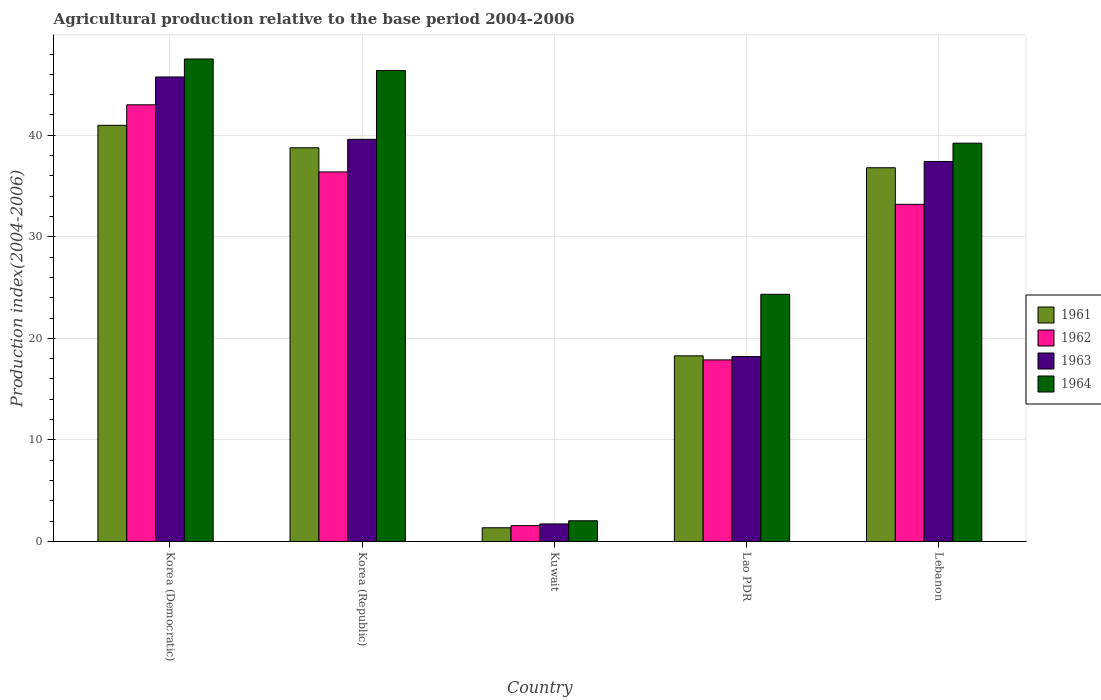How many different coloured bars are there?
Make the answer very short. 4. How many bars are there on the 5th tick from the left?
Provide a short and direct response. 4. How many bars are there on the 2nd tick from the right?
Your answer should be compact. 4. What is the label of the 5th group of bars from the left?
Provide a short and direct response. Lebanon. In how many cases, is the number of bars for a given country not equal to the number of legend labels?
Ensure brevity in your answer.  0. What is the agricultural production index in 1962 in Korea (Democratic)?
Offer a terse response. 43. Across all countries, what is the maximum agricultural production index in 1963?
Your response must be concise. 45.74. Across all countries, what is the minimum agricultural production index in 1962?
Offer a very short reply. 1.56. In which country was the agricultural production index in 1963 maximum?
Your answer should be very brief. Korea (Democratic). In which country was the agricultural production index in 1962 minimum?
Offer a very short reply. Kuwait. What is the total agricultural production index in 1963 in the graph?
Provide a succinct answer. 142.7. What is the difference between the agricultural production index in 1963 in Korea (Democratic) and that in Kuwait?
Offer a terse response. 44.01. What is the difference between the agricultural production index in 1962 in Lebanon and the agricultural production index in 1963 in Kuwait?
Your response must be concise. 31.47. What is the average agricultural production index in 1964 per country?
Ensure brevity in your answer.  31.9. What is the difference between the agricultural production index of/in 1962 and agricultural production index of/in 1963 in Kuwait?
Your answer should be very brief. -0.17. What is the ratio of the agricultural production index in 1962 in Korea (Republic) to that in Lao PDR?
Make the answer very short. 2.04. What is the difference between the highest and the second highest agricultural production index in 1961?
Make the answer very short. 4.18. What is the difference between the highest and the lowest agricultural production index in 1964?
Provide a short and direct response. 45.47. Is the sum of the agricultural production index in 1962 in Kuwait and Lebanon greater than the maximum agricultural production index in 1963 across all countries?
Your answer should be compact. No. Is it the case that in every country, the sum of the agricultural production index in 1962 and agricultural production index in 1961 is greater than the sum of agricultural production index in 1963 and agricultural production index in 1964?
Your answer should be very brief. No. What does the 4th bar from the left in Lao PDR represents?
Offer a terse response. 1964. What does the 4th bar from the right in Lao PDR represents?
Provide a succinct answer. 1961. Are the values on the major ticks of Y-axis written in scientific E-notation?
Offer a very short reply. No. Does the graph contain any zero values?
Your response must be concise. No. Where does the legend appear in the graph?
Provide a short and direct response. Center right. How many legend labels are there?
Your answer should be very brief. 4. How are the legend labels stacked?
Provide a succinct answer. Vertical. What is the title of the graph?
Offer a terse response. Agricultural production relative to the base period 2004-2006. Does "1975" appear as one of the legend labels in the graph?
Your response must be concise. No. What is the label or title of the Y-axis?
Provide a short and direct response. Production index(2004-2006). What is the Production index(2004-2006) of 1961 in Korea (Democratic)?
Make the answer very short. 40.98. What is the Production index(2004-2006) of 1962 in Korea (Democratic)?
Provide a short and direct response. 43. What is the Production index(2004-2006) in 1963 in Korea (Democratic)?
Your answer should be compact. 45.74. What is the Production index(2004-2006) in 1964 in Korea (Democratic)?
Offer a terse response. 47.51. What is the Production index(2004-2006) of 1961 in Korea (Republic)?
Provide a succinct answer. 38.77. What is the Production index(2004-2006) of 1962 in Korea (Republic)?
Offer a terse response. 36.39. What is the Production index(2004-2006) in 1963 in Korea (Republic)?
Your answer should be compact. 39.6. What is the Production index(2004-2006) in 1964 in Korea (Republic)?
Your response must be concise. 46.37. What is the Production index(2004-2006) in 1961 in Kuwait?
Ensure brevity in your answer.  1.35. What is the Production index(2004-2006) in 1962 in Kuwait?
Your answer should be compact. 1.56. What is the Production index(2004-2006) in 1963 in Kuwait?
Offer a terse response. 1.73. What is the Production index(2004-2006) in 1964 in Kuwait?
Your response must be concise. 2.04. What is the Production index(2004-2006) in 1961 in Lao PDR?
Make the answer very short. 18.28. What is the Production index(2004-2006) in 1962 in Lao PDR?
Provide a short and direct response. 17.88. What is the Production index(2004-2006) of 1963 in Lao PDR?
Make the answer very short. 18.21. What is the Production index(2004-2006) of 1964 in Lao PDR?
Offer a terse response. 24.34. What is the Production index(2004-2006) of 1961 in Lebanon?
Your response must be concise. 36.8. What is the Production index(2004-2006) in 1962 in Lebanon?
Offer a very short reply. 33.2. What is the Production index(2004-2006) of 1963 in Lebanon?
Your answer should be very brief. 37.42. What is the Production index(2004-2006) in 1964 in Lebanon?
Keep it short and to the point. 39.22. Across all countries, what is the maximum Production index(2004-2006) in 1961?
Keep it short and to the point. 40.98. Across all countries, what is the maximum Production index(2004-2006) in 1962?
Offer a very short reply. 43. Across all countries, what is the maximum Production index(2004-2006) of 1963?
Provide a succinct answer. 45.74. Across all countries, what is the maximum Production index(2004-2006) in 1964?
Your answer should be compact. 47.51. Across all countries, what is the minimum Production index(2004-2006) of 1961?
Offer a terse response. 1.35. Across all countries, what is the minimum Production index(2004-2006) of 1962?
Provide a succinct answer. 1.56. Across all countries, what is the minimum Production index(2004-2006) of 1963?
Make the answer very short. 1.73. Across all countries, what is the minimum Production index(2004-2006) in 1964?
Your answer should be very brief. 2.04. What is the total Production index(2004-2006) in 1961 in the graph?
Make the answer very short. 136.18. What is the total Production index(2004-2006) in 1962 in the graph?
Your answer should be compact. 132.03. What is the total Production index(2004-2006) in 1963 in the graph?
Your answer should be very brief. 142.7. What is the total Production index(2004-2006) in 1964 in the graph?
Give a very brief answer. 159.48. What is the difference between the Production index(2004-2006) of 1961 in Korea (Democratic) and that in Korea (Republic)?
Your response must be concise. 2.21. What is the difference between the Production index(2004-2006) of 1962 in Korea (Democratic) and that in Korea (Republic)?
Offer a very short reply. 6.61. What is the difference between the Production index(2004-2006) in 1963 in Korea (Democratic) and that in Korea (Republic)?
Offer a terse response. 6.14. What is the difference between the Production index(2004-2006) of 1964 in Korea (Democratic) and that in Korea (Republic)?
Your answer should be very brief. 1.14. What is the difference between the Production index(2004-2006) in 1961 in Korea (Democratic) and that in Kuwait?
Ensure brevity in your answer.  39.63. What is the difference between the Production index(2004-2006) of 1962 in Korea (Democratic) and that in Kuwait?
Provide a short and direct response. 41.44. What is the difference between the Production index(2004-2006) in 1963 in Korea (Democratic) and that in Kuwait?
Offer a very short reply. 44.01. What is the difference between the Production index(2004-2006) in 1964 in Korea (Democratic) and that in Kuwait?
Give a very brief answer. 45.47. What is the difference between the Production index(2004-2006) in 1961 in Korea (Democratic) and that in Lao PDR?
Your answer should be very brief. 22.7. What is the difference between the Production index(2004-2006) in 1962 in Korea (Democratic) and that in Lao PDR?
Your response must be concise. 25.12. What is the difference between the Production index(2004-2006) of 1963 in Korea (Democratic) and that in Lao PDR?
Give a very brief answer. 27.53. What is the difference between the Production index(2004-2006) in 1964 in Korea (Democratic) and that in Lao PDR?
Offer a terse response. 23.17. What is the difference between the Production index(2004-2006) of 1961 in Korea (Democratic) and that in Lebanon?
Give a very brief answer. 4.18. What is the difference between the Production index(2004-2006) in 1963 in Korea (Democratic) and that in Lebanon?
Offer a very short reply. 8.32. What is the difference between the Production index(2004-2006) in 1964 in Korea (Democratic) and that in Lebanon?
Offer a very short reply. 8.29. What is the difference between the Production index(2004-2006) of 1961 in Korea (Republic) and that in Kuwait?
Your response must be concise. 37.42. What is the difference between the Production index(2004-2006) of 1962 in Korea (Republic) and that in Kuwait?
Provide a succinct answer. 34.83. What is the difference between the Production index(2004-2006) in 1963 in Korea (Republic) and that in Kuwait?
Ensure brevity in your answer.  37.87. What is the difference between the Production index(2004-2006) of 1964 in Korea (Republic) and that in Kuwait?
Your response must be concise. 44.33. What is the difference between the Production index(2004-2006) of 1961 in Korea (Republic) and that in Lao PDR?
Your answer should be very brief. 20.49. What is the difference between the Production index(2004-2006) in 1962 in Korea (Republic) and that in Lao PDR?
Provide a short and direct response. 18.51. What is the difference between the Production index(2004-2006) of 1963 in Korea (Republic) and that in Lao PDR?
Ensure brevity in your answer.  21.39. What is the difference between the Production index(2004-2006) of 1964 in Korea (Republic) and that in Lao PDR?
Your answer should be compact. 22.03. What is the difference between the Production index(2004-2006) of 1961 in Korea (Republic) and that in Lebanon?
Provide a succinct answer. 1.97. What is the difference between the Production index(2004-2006) in 1962 in Korea (Republic) and that in Lebanon?
Your response must be concise. 3.19. What is the difference between the Production index(2004-2006) in 1963 in Korea (Republic) and that in Lebanon?
Your answer should be compact. 2.18. What is the difference between the Production index(2004-2006) in 1964 in Korea (Republic) and that in Lebanon?
Offer a terse response. 7.15. What is the difference between the Production index(2004-2006) in 1961 in Kuwait and that in Lao PDR?
Give a very brief answer. -16.93. What is the difference between the Production index(2004-2006) of 1962 in Kuwait and that in Lao PDR?
Offer a very short reply. -16.32. What is the difference between the Production index(2004-2006) of 1963 in Kuwait and that in Lao PDR?
Make the answer very short. -16.48. What is the difference between the Production index(2004-2006) of 1964 in Kuwait and that in Lao PDR?
Keep it short and to the point. -22.3. What is the difference between the Production index(2004-2006) of 1961 in Kuwait and that in Lebanon?
Ensure brevity in your answer.  -35.45. What is the difference between the Production index(2004-2006) of 1962 in Kuwait and that in Lebanon?
Ensure brevity in your answer.  -31.64. What is the difference between the Production index(2004-2006) in 1963 in Kuwait and that in Lebanon?
Your response must be concise. -35.69. What is the difference between the Production index(2004-2006) in 1964 in Kuwait and that in Lebanon?
Provide a succinct answer. -37.18. What is the difference between the Production index(2004-2006) of 1961 in Lao PDR and that in Lebanon?
Provide a succinct answer. -18.52. What is the difference between the Production index(2004-2006) of 1962 in Lao PDR and that in Lebanon?
Make the answer very short. -15.32. What is the difference between the Production index(2004-2006) in 1963 in Lao PDR and that in Lebanon?
Offer a terse response. -19.21. What is the difference between the Production index(2004-2006) in 1964 in Lao PDR and that in Lebanon?
Offer a terse response. -14.88. What is the difference between the Production index(2004-2006) of 1961 in Korea (Democratic) and the Production index(2004-2006) of 1962 in Korea (Republic)?
Offer a terse response. 4.59. What is the difference between the Production index(2004-2006) of 1961 in Korea (Democratic) and the Production index(2004-2006) of 1963 in Korea (Republic)?
Ensure brevity in your answer.  1.38. What is the difference between the Production index(2004-2006) of 1961 in Korea (Democratic) and the Production index(2004-2006) of 1964 in Korea (Republic)?
Your response must be concise. -5.39. What is the difference between the Production index(2004-2006) in 1962 in Korea (Democratic) and the Production index(2004-2006) in 1964 in Korea (Republic)?
Give a very brief answer. -3.37. What is the difference between the Production index(2004-2006) of 1963 in Korea (Democratic) and the Production index(2004-2006) of 1964 in Korea (Republic)?
Offer a terse response. -0.63. What is the difference between the Production index(2004-2006) in 1961 in Korea (Democratic) and the Production index(2004-2006) in 1962 in Kuwait?
Your answer should be very brief. 39.42. What is the difference between the Production index(2004-2006) of 1961 in Korea (Democratic) and the Production index(2004-2006) of 1963 in Kuwait?
Your answer should be compact. 39.25. What is the difference between the Production index(2004-2006) in 1961 in Korea (Democratic) and the Production index(2004-2006) in 1964 in Kuwait?
Your response must be concise. 38.94. What is the difference between the Production index(2004-2006) in 1962 in Korea (Democratic) and the Production index(2004-2006) in 1963 in Kuwait?
Ensure brevity in your answer.  41.27. What is the difference between the Production index(2004-2006) in 1962 in Korea (Democratic) and the Production index(2004-2006) in 1964 in Kuwait?
Keep it short and to the point. 40.96. What is the difference between the Production index(2004-2006) of 1963 in Korea (Democratic) and the Production index(2004-2006) of 1964 in Kuwait?
Give a very brief answer. 43.7. What is the difference between the Production index(2004-2006) of 1961 in Korea (Democratic) and the Production index(2004-2006) of 1962 in Lao PDR?
Your answer should be compact. 23.1. What is the difference between the Production index(2004-2006) of 1961 in Korea (Democratic) and the Production index(2004-2006) of 1963 in Lao PDR?
Give a very brief answer. 22.77. What is the difference between the Production index(2004-2006) in 1961 in Korea (Democratic) and the Production index(2004-2006) in 1964 in Lao PDR?
Give a very brief answer. 16.64. What is the difference between the Production index(2004-2006) in 1962 in Korea (Democratic) and the Production index(2004-2006) in 1963 in Lao PDR?
Your answer should be compact. 24.79. What is the difference between the Production index(2004-2006) in 1962 in Korea (Democratic) and the Production index(2004-2006) in 1964 in Lao PDR?
Ensure brevity in your answer.  18.66. What is the difference between the Production index(2004-2006) in 1963 in Korea (Democratic) and the Production index(2004-2006) in 1964 in Lao PDR?
Offer a very short reply. 21.4. What is the difference between the Production index(2004-2006) in 1961 in Korea (Democratic) and the Production index(2004-2006) in 1962 in Lebanon?
Provide a short and direct response. 7.78. What is the difference between the Production index(2004-2006) in 1961 in Korea (Democratic) and the Production index(2004-2006) in 1963 in Lebanon?
Your answer should be very brief. 3.56. What is the difference between the Production index(2004-2006) in 1961 in Korea (Democratic) and the Production index(2004-2006) in 1964 in Lebanon?
Your answer should be very brief. 1.76. What is the difference between the Production index(2004-2006) of 1962 in Korea (Democratic) and the Production index(2004-2006) of 1963 in Lebanon?
Your answer should be very brief. 5.58. What is the difference between the Production index(2004-2006) in 1962 in Korea (Democratic) and the Production index(2004-2006) in 1964 in Lebanon?
Keep it short and to the point. 3.78. What is the difference between the Production index(2004-2006) of 1963 in Korea (Democratic) and the Production index(2004-2006) of 1964 in Lebanon?
Keep it short and to the point. 6.52. What is the difference between the Production index(2004-2006) in 1961 in Korea (Republic) and the Production index(2004-2006) in 1962 in Kuwait?
Offer a very short reply. 37.21. What is the difference between the Production index(2004-2006) of 1961 in Korea (Republic) and the Production index(2004-2006) of 1963 in Kuwait?
Offer a very short reply. 37.04. What is the difference between the Production index(2004-2006) of 1961 in Korea (Republic) and the Production index(2004-2006) of 1964 in Kuwait?
Your answer should be very brief. 36.73. What is the difference between the Production index(2004-2006) in 1962 in Korea (Republic) and the Production index(2004-2006) in 1963 in Kuwait?
Your response must be concise. 34.66. What is the difference between the Production index(2004-2006) in 1962 in Korea (Republic) and the Production index(2004-2006) in 1964 in Kuwait?
Keep it short and to the point. 34.35. What is the difference between the Production index(2004-2006) in 1963 in Korea (Republic) and the Production index(2004-2006) in 1964 in Kuwait?
Give a very brief answer. 37.56. What is the difference between the Production index(2004-2006) of 1961 in Korea (Republic) and the Production index(2004-2006) of 1962 in Lao PDR?
Provide a short and direct response. 20.89. What is the difference between the Production index(2004-2006) in 1961 in Korea (Republic) and the Production index(2004-2006) in 1963 in Lao PDR?
Give a very brief answer. 20.56. What is the difference between the Production index(2004-2006) of 1961 in Korea (Republic) and the Production index(2004-2006) of 1964 in Lao PDR?
Provide a succinct answer. 14.43. What is the difference between the Production index(2004-2006) in 1962 in Korea (Republic) and the Production index(2004-2006) in 1963 in Lao PDR?
Your response must be concise. 18.18. What is the difference between the Production index(2004-2006) in 1962 in Korea (Republic) and the Production index(2004-2006) in 1964 in Lao PDR?
Offer a terse response. 12.05. What is the difference between the Production index(2004-2006) of 1963 in Korea (Republic) and the Production index(2004-2006) of 1964 in Lao PDR?
Provide a short and direct response. 15.26. What is the difference between the Production index(2004-2006) in 1961 in Korea (Republic) and the Production index(2004-2006) in 1962 in Lebanon?
Provide a short and direct response. 5.57. What is the difference between the Production index(2004-2006) of 1961 in Korea (Republic) and the Production index(2004-2006) of 1963 in Lebanon?
Provide a succinct answer. 1.35. What is the difference between the Production index(2004-2006) in 1961 in Korea (Republic) and the Production index(2004-2006) in 1964 in Lebanon?
Offer a terse response. -0.45. What is the difference between the Production index(2004-2006) in 1962 in Korea (Republic) and the Production index(2004-2006) in 1963 in Lebanon?
Make the answer very short. -1.03. What is the difference between the Production index(2004-2006) of 1962 in Korea (Republic) and the Production index(2004-2006) of 1964 in Lebanon?
Make the answer very short. -2.83. What is the difference between the Production index(2004-2006) of 1963 in Korea (Republic) and the Production index(2004-2006) of 1964 in Lebanon?
Provide a succinct answer. 0.38. What is the difference between the Production index(2004-2006) in 1961 in Kuwait and the Production index(2004-2006) in 1962 in Lao PDR?
Provide a short and direct response. -16.53. What is the difference between the Production index(2004-2006) of 1961 in Kuwait and the Production index(2004-2006) of 1963 in Lao PDR?
Ensure brevity in your answer.  -16.86. What is the difference between the Production index(2004-2006) in 1961 in Kuwait and the Production index(2004-2006) in 1964 in Lao PDR?
Offer a terse response. -22.99. What is the difference between the Production index(2004-2006) of 1962 in Kuwait and the Production index(2004-2006) of 1963 in Lao PDR?
Provide a succinct answer. -16.65. What is the difference between the Production index(2004-2006) of 1962 in Kuwait and the Production index(2004-2006) of 1964 in Lao PDR?
Offer a very short reply. -22.78. What is the difference between the Production index(2004-2006) in 1963 in Kuwait and the Production index(2004-2006) in 1964 in Lao PDR?
Your response must be concise. -22.61. What is the difference between the Production index(2004-2006) in 1961 in Kuwait and the Production index(2004-2006) in 1962 in Lebanon?
Provide a short and direct response. -31.85. What is the difference between the Production index(2004-2006) in 1961 in Kuwait and the Production index(2004-2006) in 1963 in Lebanon?
Provide a short and direct response. -36.07. What is the difference between the Production index(2004-2006) of 1961 in Kuwait and the Production index(2004-2006) of 1964 in Lebanon?
Give a very brief answer. -37.87. What is the difference between the Production index(2004-2006) of 1962 in Kuwait and the Production index(2004-2006) of 1963 in Lebanon?
Your answer should be very brief. -35.86. What is the difference between the Production index(2004-2006) in 1962 in Kuwait and the Production index(2004-2006) in 1964 in Lebanon?
Offer a terse response. -37.66. What is the difference between the Production index(2004-2006) of 1963 in Kuwait and the Production index(2004-2006) of 1964 in Lebanon?
Offer a very short reply. -37.49. What is the difference between the Production index(2004-2006) in 1961 in Lao PDR and the Production index(2004-2006) in 1962 in Lebanon?
Your answer should be very brief. -14.92. What is the difference between the Production index(2004-2006) in 1961 in Lao PDR and the Production index(2004-2006) in 1963 in Lebanon?
Offer a very short reply. -19.14. What is the difference between the Production index(2004-2006) of 1961 in Lao PDR and the Production index(2004-2006) of 1964 in Lebanon?
Make the answer very short. -20.94. What is the difference between the Production index(2004-2006) in 1962 in Lao PDR and the Production index(2004-2006) in 1963 in Lebanon?
Provide a short and direct response. -19.54. What is the difference between the Production index(2004-2006) in 1962 in Lao PDR and the Production index(2004-2006) in 1964 in Lebanon?
Keep it short and to the point. -21.34. What is the difference between the Production index(2004-2006) of 1963 in Lao PDR and the Production index(2004-2006) of 1964 in Lebanon?
Your response must be concise. -21.01. What is the average Production index(2004-2006) in 1961 per country?
Ensure brevity in your answer.  27.24. What is the average Production index(2004-2006) in 1962 per country?
Keep it short and to the point. 26.41. What is the average Production index(2004-2006) in 1963 per country?
Keep it short and to the point. 28.54. What is the average Production index(2004-2006) of 1964 per country?
Make the answer very short. 31.9. What is the difference between the Production index(2004-2006) of 1961 and Production index(2004-2006) of 1962 in Korea (Democratic)?
Provide a short and direct response. -2.02. What is the difference between the Production index(2004-2006) of 1961 and Production index(2004-2006) of 1963 in Korea (Democratic)?
Your answer should be compact. -4.76. What is the difference between the Production index(2004-2006) in 1961 and Production index(2004-2006) in 1964 in Korea (Democratic)?
Your answer should be compact. -6.53. What is the difference between the Production index(2004-2006) of 1962 and Production index(2004-2006) of 1963 in Korea (Democratic)?
Offer a very short reply. -2.74. What is the difference between the Production index(2004-2006) in 1962 and Production index(2004-2006) in 1964 in Korea (Democratic)?
Ensure brevity in your answer.  -4.51. What is the difference between the Production index(2004-2006) of 1963 and Production index(2004-2006) of 1964 in Korea (Democratic)?
Ensure brevity in your answer.  -1.77. What is the difference between the Production index(2004-2006) of 1961 and Production index(2004-2006) of 1962 in Korea (Republic)?
Offer a terse response. 2.38. What is the difference between the Production index(2004-2006) in 1961 and Production index(2004-2006) in 1963 in Korea (Republic)?
Provide a succinct answer. -0.83. What is the difference between the Production index(2004-2006) of 1962 and Production index(2004-2006) of 1963 in Korea (Republic)?
Ensure brevity in your answer.  -3.21. What is the difference between the Production index(2004-2006) of 1962 and Production index(2004-2006) of 1964 in Korea (Republic)?
Keep it short and to the point. -9.98. What is the difference between the Production index(2004-2006) in 1963 and Production index(2004-2006) in 1964 in Korea (Republic)?
Ensure brevity in your answer.  -6.77. What is the difference between the Production index(2004-2006) of 1961 and Production index(2004-2006) of 1962 in Kuwait?
Your response must be concise. -0.21. What is the difference between the Production index(2004-2006) of 1961 and Production index(2004-2006) of 1963 in Kuwait?
Your answer should be compact. -0.38. What is the difference between the Production index(2004-2006) of 1961 and Production index(2004-2006) of 1964 in Kuwait?
Give a very brief answer. -0.69. What is the difference between the Production index(2004-2006) in 1962 and Production index(2004-2006) in 1963 in Kuwait?
Offer a terse response. -0.17. What is the difference between the Production index(2004-2006) in 1962 and Production index(2004-2006) in 1964 in Kuwait?
Provide a succinct answer. -0.48. What is the difference between the Production index(2004-2006) of 1963 and Production index(2004-2006) of 1964 in Kuwait?
Your response must be concise. -0.31. What is the difference between the Production index(2004-2006) of 1961 and Production index(2004-2006) of 1962 in Lao PDR?
Your answer should be compact. 0.4. What is the difference between the Production index(2004-2006) in 1961 and Production index(2004-2006) in 1963 in Lao PDR?
Offer a terse response. 0.07. What is the difference between the Production index(2004-2006) of 1961 and Production index(2004-2006) of 1964 in Lao PDR?
Give a very brief answer. -6.06. What is the difference between the Production index(2004-2006) of 1962 and Production index(2004-2006) of 1963 in Lao PDR?
Keep it short and to the point. -0.33. What is the difference between the Production index(2004-2006) of 1962 and Production index(2004-2006) of 1964 in Lao PDR?
Offer a terse response. -6.46. What is the difference between the Production index(2004-2006) of 1963 and Production index(2004-2006) of 1964 in Lao PDR?
Ensure brevity in your answer.  -6.13. What is the difference between the Production index(2004-2006) of 1961 and Production index(2004-2006) of 1963 in Lebanon?
Your answer should be compact. -0.62. What is the difference between the Production index(2004-2006) of 1961 and Production index(2004-2006) of 1964 in Lebanon?
Keep it short and to the point. -2.42. What is the difference between the Production index(2004-2006) in 1962 and Production index(2004-2006) in 1963 in Lebanon?
Provide a succinct answer. -4.22. What is the difference between the Production index(2004-2006) in 1962 and Production index(2004-2006) in 1964 in Lebanon?
Ensure brevity in your answer.  -6.02. What is the difference between the Production index(2004-2006) in 1963 and Production index(2004-2006) in 1964 in Lebanon?
Provide a succinct answer. -1.8. What is the ratio of the Production index(2004-2006) of 1961 in Korea (Democratic) to that in Korea (Republic)?
Your answer should be compact. 1.06. What is the ratio of the Production index(2004-2006) of 1962 in Korea (Democratic) to that in Korea (Republic)?
Offer a very short reply. 1.18. What is the ratio of the Production index(2004-2006) in 1963 in Korea (Democratic) to that in Korea (Republic)?
Ensure brevity in your answer.  1.16. What is the ratio of the Production index(2004-2006) in 1964 in Korea (Democratic) to that in Korea (Republic)?
Ensure brevity in your answer.  1.02. What is the ratio of the Production index(2004-2006) in 1961 in Korea (Democratic) to that in Kuwait?
Your response must be concise. 30.36. What is the ratio of the Production index(2004-2006) in 1962 in Korea (Democratic) to that in Kuwait?
Give a very brief answer. 27.56. What is the ratio of the Production index(2004-2006) in 1963 in Korea (Democratic) to that in Kuwait?
Offer a terse response. 26.44. What is the ratio of the Production index(2004-2006) of 1964 in Korea (Democratic) to that in Kuwait?
Offer a terse response. 23.29. What is the ratio of the Production index(2004-2006) of 1961 in Korea (Democratic) to that in Lao PDR?
Keep it short and to the point. 2.24. What is the ratio of the Production index(2004-2006) in 1962 in Korea (Democratic) to that in Lao PDR?
Keep it short and to the point. 2.4. What is the ratio of the Production index(2004-2006) of 1963 in Korea (Democratic) to that in Lao PDR?
Keep it short and to the point. 2.51. What is the ratio of the Production index(2004-2006) in 1964 in Korea (Democratic) to that in Lao PDR?
Your answer should be compact. 1.95. What is the ratio of the Production index(2004-2006) of 1961 in Korea (Democratic) to that in Lebanon?
Keep it short and to the point. 1.11. What is the ratio of the Production index(2004-2006) of 1962 in Korea (Democratic) to that in Lebanon?
Your answer should be very brief. 1.3. What is the ratio of the Production index(2004-2006) of 1963 in Korea (Democratic) to that in Lebanon?
Offer a terse response. 1.22. What is the ratio of the Production index(2004-2006) in 1964 in Korea (Democratic) to that in Lebanon?
Provide a succinct answer. 1.21. What is the ratio of the Production index(2004-2006) in 1961 in Korea (Republic) to that in Kuwait?
Your answer should be very brief. 28.72. What is the ratio of the Production index(2004-2006) of 1962 in Korea (Republic) to that in Kuwait?
Keep it short and to the point. 23.33. What is the ratio of the Production index(2004-2006) of 1963 in Korea (Republic) to that in Kuwait?
Ensure brevity in your answer.  22.89. What is the ratio of the Production index(2004-2006) in 1964 in Korea (Republic) to that in Kuwait?
Keep it short and to the point. 22.73. What is the ratio of the Production index(2004-2006) of 1961 in Korea (Republic) to that in Lao PDR?
Your answer should be compact. 2.12. What is the ratio of the Production index(2004-2006) of 1962 in Korea (Republic) to that in Lao PDR?
Offer a very short reply. 2.04. What is the ratio of the Production index(2004-2006) in 1963 in Korea (Republic) to that in Lao PDR?
Offer a very short reply. 2.17. What is the ratio of the Production index(2004-2006) in 1964 in Korea (Republic) to that in Lao PDR?
Offer a terse response. 1.91. What is the ratio of the Production index(2004-2006) in 1961 in Korea (Republic) to that in Lebanon?
Give a very brief answer. 1.05. What is the ratio of the Production index(2004-2006) in 1962 in Korea (Republic) to that in Lebanon?
Offer a terse response. 1.1. What is the ratio of the Production index(2004-2006) in 1963 in Korea (Republic) to that in Lebanon?
Ensure brevity in your answer.  1.06. What is the ratio of the Production index(2004-2006) of 1964 in Korea (Republic) to that in Lebanon?
Provide a succinct answer. 1.18. What is the ratio of the Production index(2004-2006) in 1961 in Kuwait to that in Lao PDR?
Provide a succinct answer. 0.07. What is the ratio of the Production index(2004-2006) of 1962 in Kuwait to that in Lao PDR?
Give a very brief answer. 0.09. What is the ratio of the Production index(2004-2006) in 1963 in Kuwait to that in Lao PDR?
Provide a short and direct response. 0.1. What is the ratio of the Production index(2004-2006) in 1964 in Kuwait to that in Lao PDR?
Offer a very short reply. 0.08. What is the ratio of the Production index(2004-2006) of 1961 in Kuwait to that in Lebanon?
Give a very brief answer. 0.04. What is the ratio of the Production index(2004-2006) in 1962 in Kuwait to that in Lebanon?
Provide a succinct answer. 0.05. What is the ratio of the Production index(2004-2006) of 1963 in Kuwait to that in Lebanon?
Ensure brevity in your answer.  0.05. What is the ratio of the Production index(2004-2006) of 1964 in Kuwait to that in Lebanon?
Keep it short and to the point. 0.05. What is the ratio of the Production index(2004-2006) in 1961 in Lao PDR to that in Lebanon?
Keep it short and to the point. 0.5. What is the ratio of the Production index(2004-2006) of 1962 in Lao PDR to that in Lebanon?
Your answer should be very brief. 0.54. What is the ratio of the Production index(2004-2006) in 1963 in Lao PDR to that in Lebanon?
Keep it short and to the point. 0.49. What is the ratio of the Production index(2004-2006) in 1964 in Lao PDR to that in Lebanon?
Your answer should be very brief. 0.62. What is the difference between the highest and the second highest Production index(2004-2006) of 1961?
Offer a terse response. 2.21. What is the difference between the highest and the second highest Production index(2004-2006) in 1962?
Make the answer very short. 6.61. What is the difference between the highest and the second highest Production index(2004-2006) in 1963?
Your response must be concise. 6.14. What is the difference between the highest and the second highest Production index(2004-2006) in 1964?
Your answer should be compact. 1.14. What is the difference between the highest and the lowest Production index(2004-2006) in 1961?
Ensure brevity in your answer.  39.63. What is the difference between the highest and the lowest Production index(2004-2006) in 1962?
Your response must be concise. 41.44. What is the difference between the highest and the lowest Production index(2004-2006) in 1963?
Provide a succinct answer. 44.01. What is the difference between the highest and the lowest Production index(2004-2006) of 1964?
Make the answer very short. 45.47. 